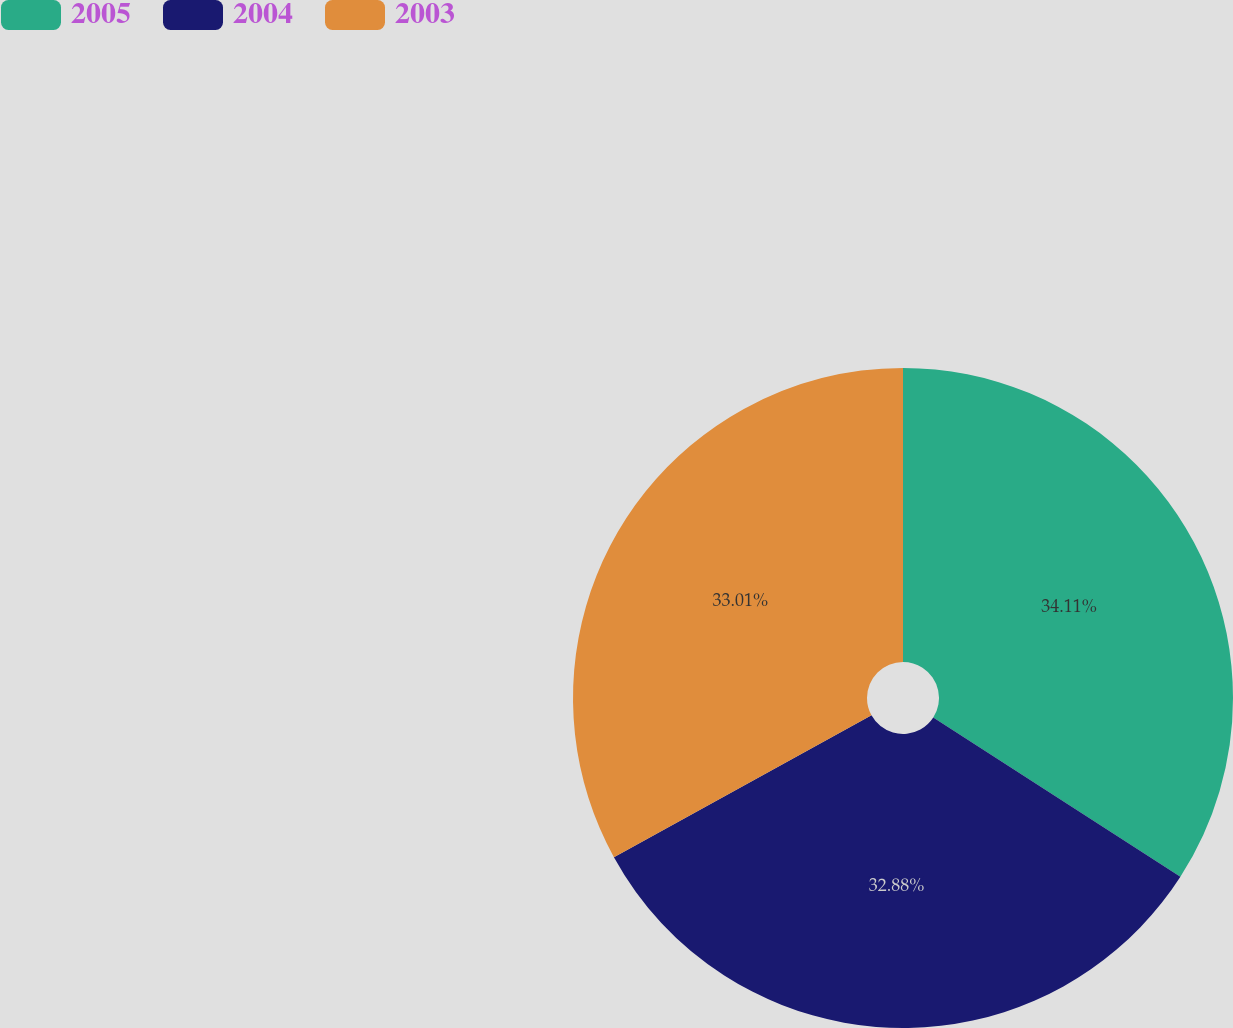Convert chart to OTSL. <chart><loc_0><loc_0><loc_500><loc_500><pie_chart><fcel>2005<fcel>2004<fcel>2003<nl><fcel>34.11%<fcel>32.88%<fcel>33.01%<nl></chart> 